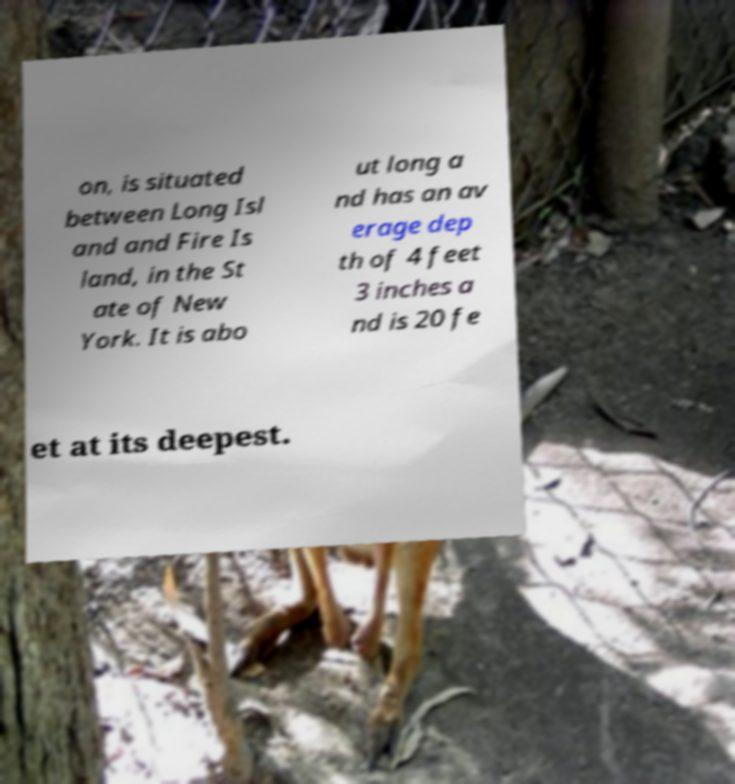There's text embedded in this image that I need extracted. Can you transcribe it verbatim? on, is situated between Long Isl and and Fire Is land, in the St ate of New York. It is abo ut long a nd has an av erage dep th of 4 feet 3 inches a nd is 20 fe et at its deepest. 